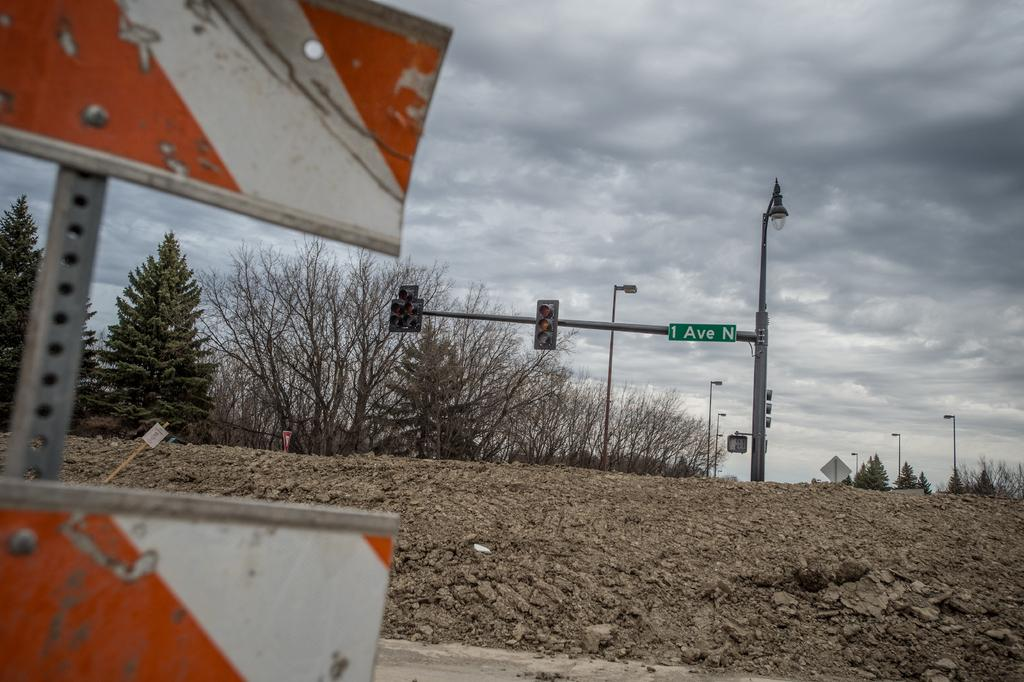Provide a one-sentence caption for the provided image. A stop light with the sign 1 Ave N attached to the top right shown on a hazy day. 